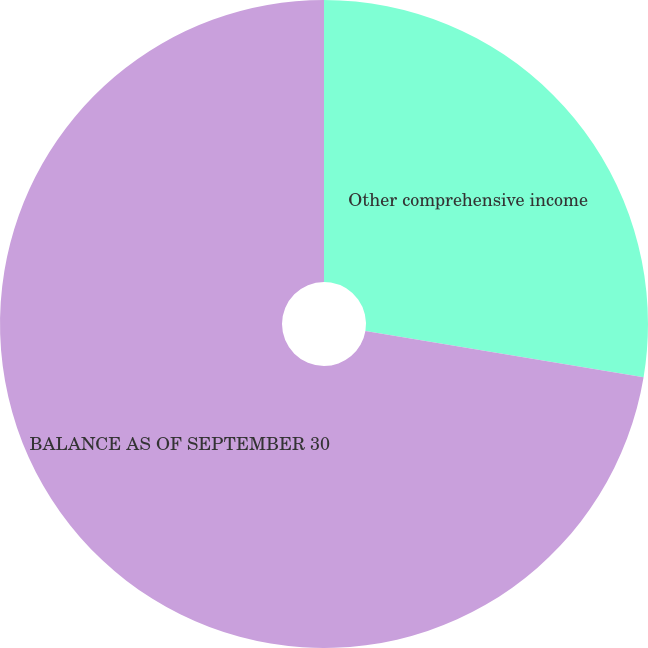Convert chart to OTSL. <chart><loc_0><loc_0><loc_500><loc_500><pie_chart><fcel>Other comprehensive income<fcel>BALANCE AS OF SEPTEMBER 30<nl><fcel>27.63%<fcel>72.37%<nl></chart> 